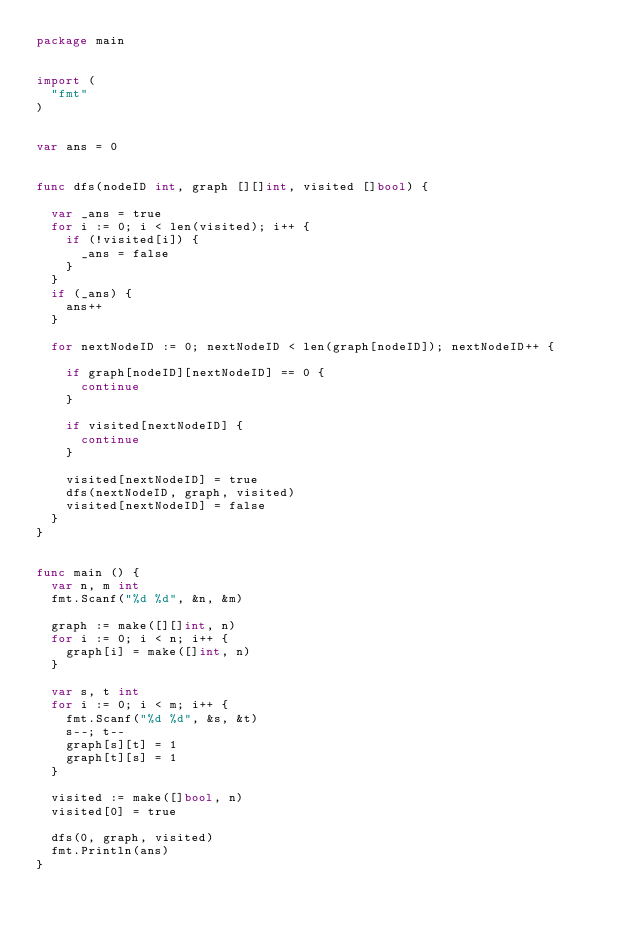Convert code to text. <code><loc_0><loc_0><loc_500><loc_500><_Go_>package main


import (
  "fmt"
)


var ans = 0


func dfs(nodeID int, graph [][]int, visited []bool) {

  var _ans = true
  for i := 0; i < len(visited); i++ {
    if (!visited[i]) {
      _ans = false
    }
  }
  if (_ans) {
    ans++
  }

  for nextNodeID := 0; nextNodeID < len(graph[nodeID]); nextNodeID++ {

    if graph[nodeID][nextNodeID] == 0 {
      continue
    }

    if visited[nextNodeID] {
      continue
    }

		visited[nextNodeID] = true
    dfs(nextNodeID, graph, visited)
    visited[nextNodeID] = false
  }
}


func main () {
  var n, m int
  fmt.Scanf("%d %d", &n, &m)

  graph := make([][]int, n)
  for i := 0; i < n; i++ {
    graph[i] = make([]int, n)
  }

  var s, t int
  for i := 0; i < m; i++ {
    fmt.Scanf("%d %d", &s, &t)
    s--; t--
    graph[s][t] = 1
    graph[t][s] = 1
  }

  visited := make([]bool, n)
  visited[0] = true

  dfs(0, graph, visited)
  fmt.Println(ans)
}
</code> 